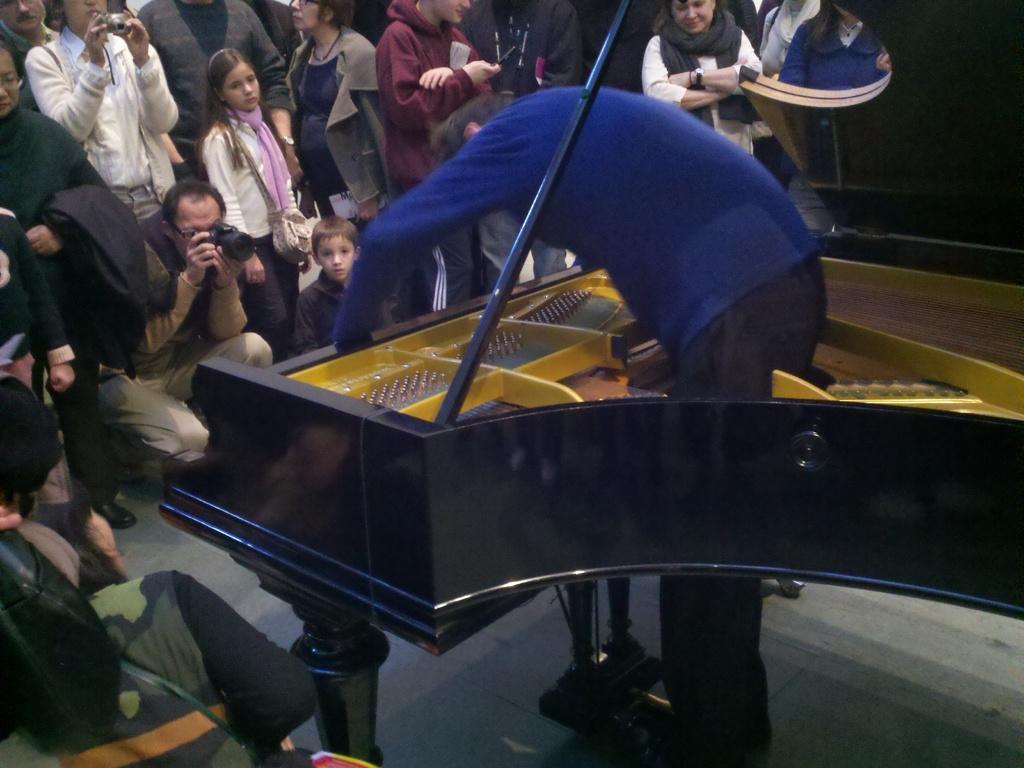Describe this image in one or two sentences. In this picture we can see a man bending and folding table and in front of him we can see a group of people where some are holding cameras with their hands and taking pictures and on right side we can see wall. 